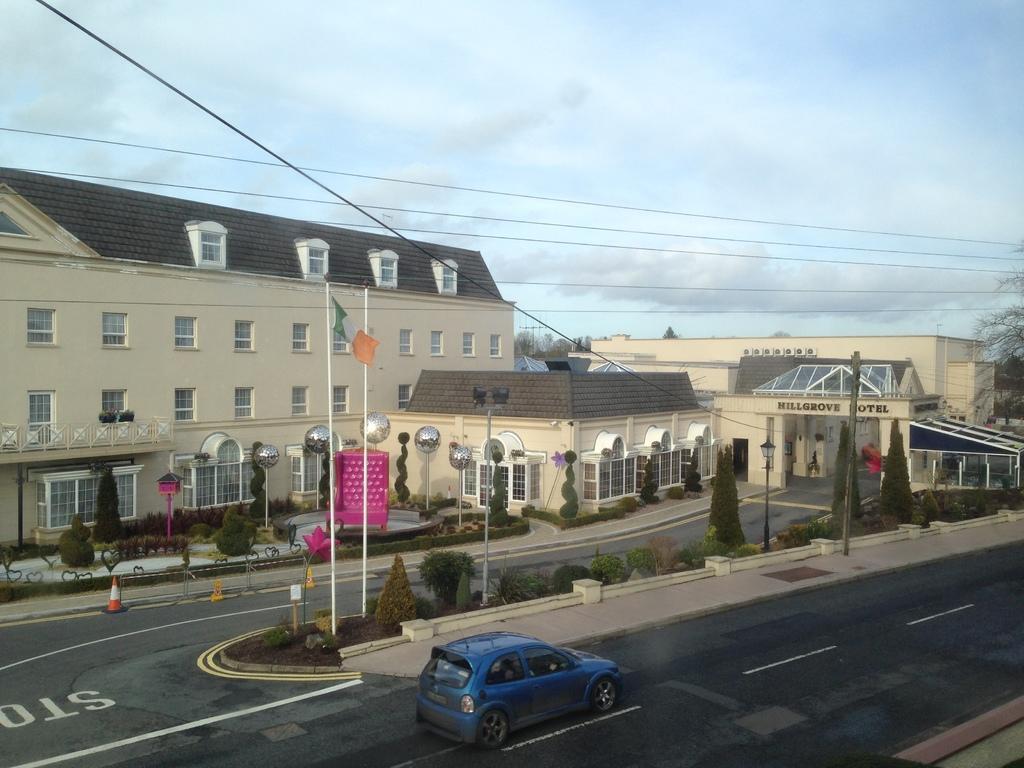In one or two sentences, can you explain what this image depicts? In this picture there is a blue color car car on the road. Behind there is a yellow color house with many windows and tile roofing on the top. Above there is a blue sky and clouds. 